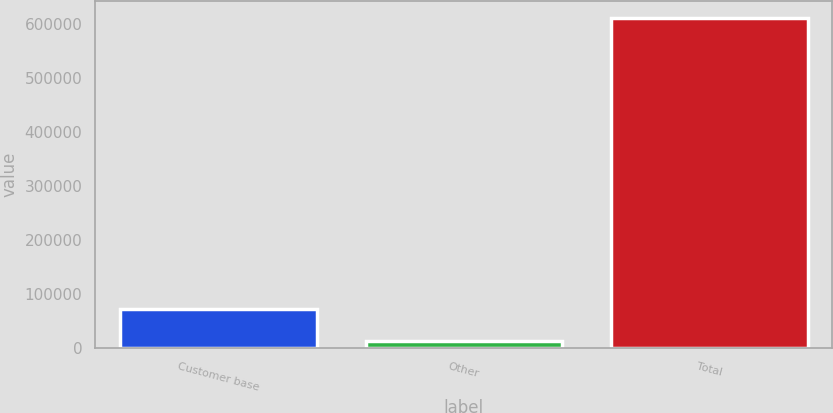<chart> <loc_0><loc_0><loc_500><loc_500><bar_chart><fcel>Customer base<fcel>Other<fcel>Total<nl><fcel>73389.3<fcel>13546<fcel>611979<nl></chart> 